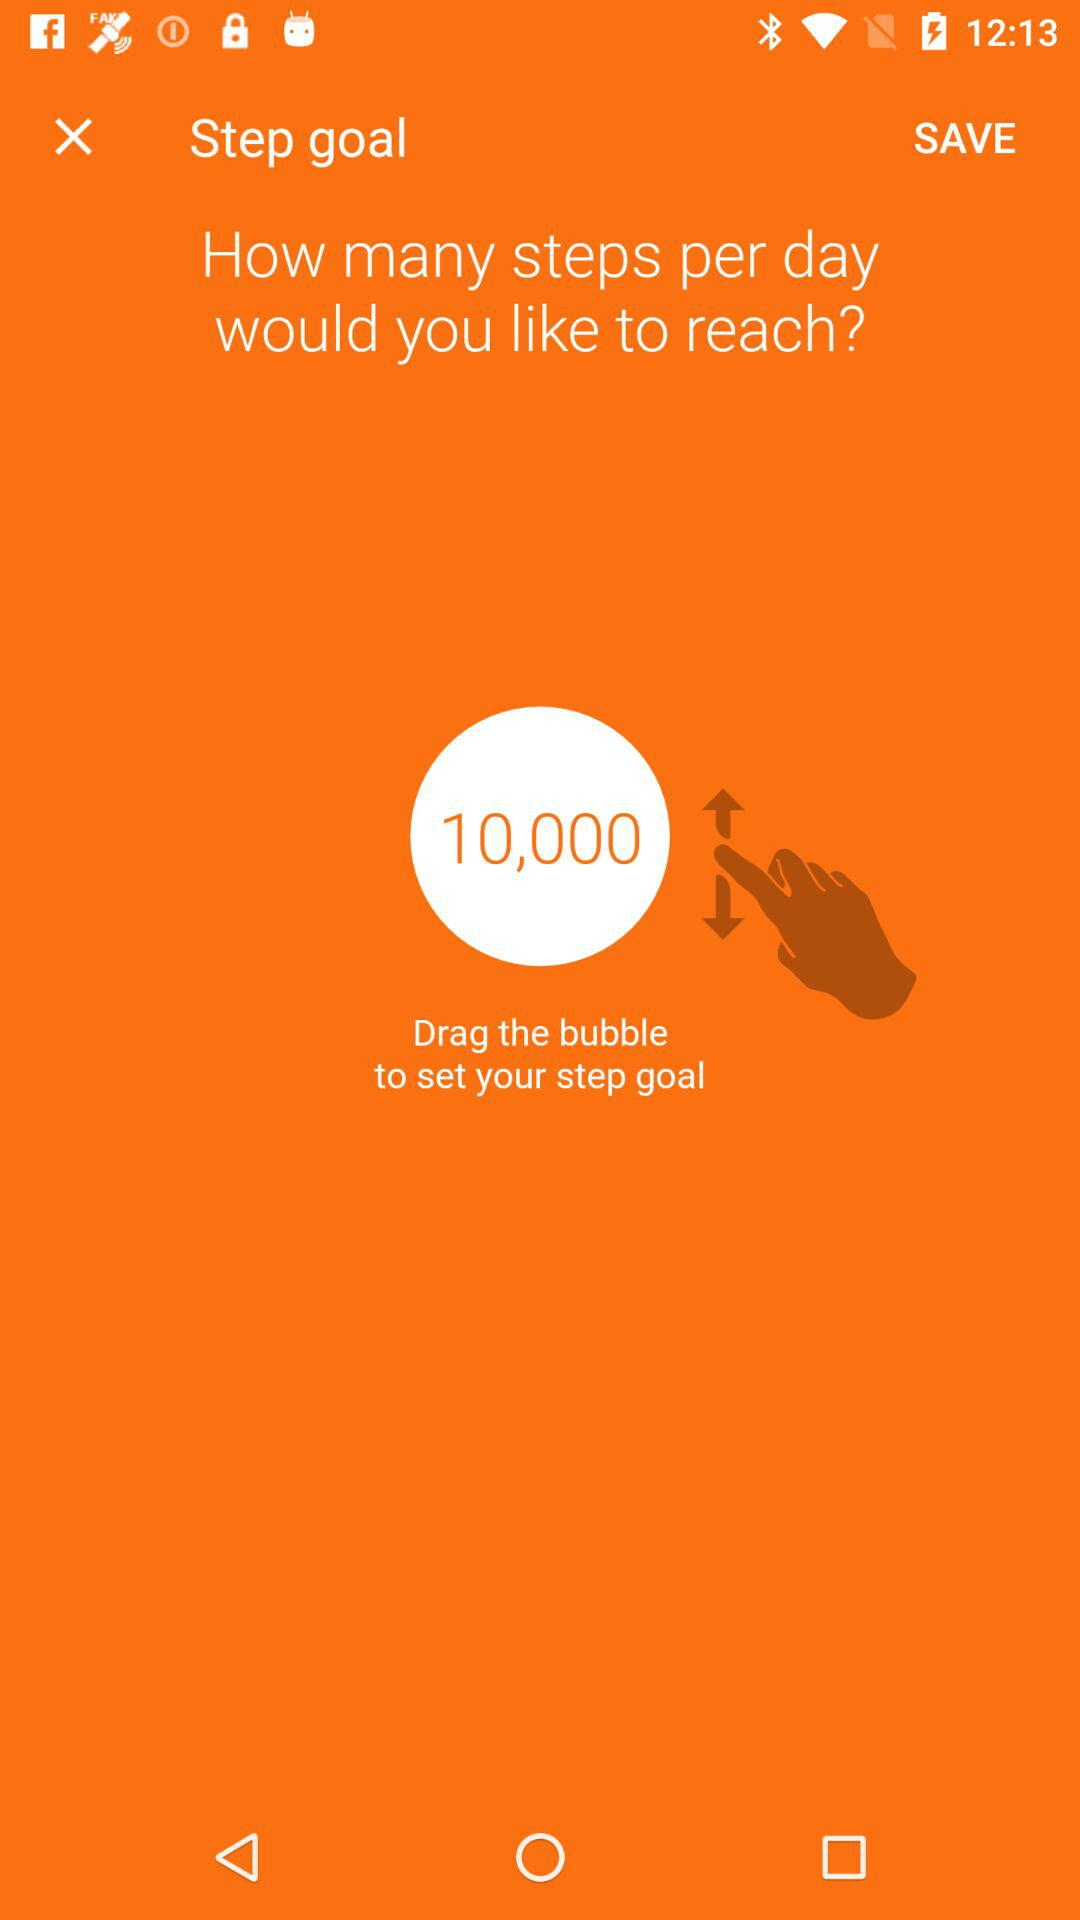How many steps are goals per day?
When the provided information is insufficient, respond with <no answer>. <no answer> 